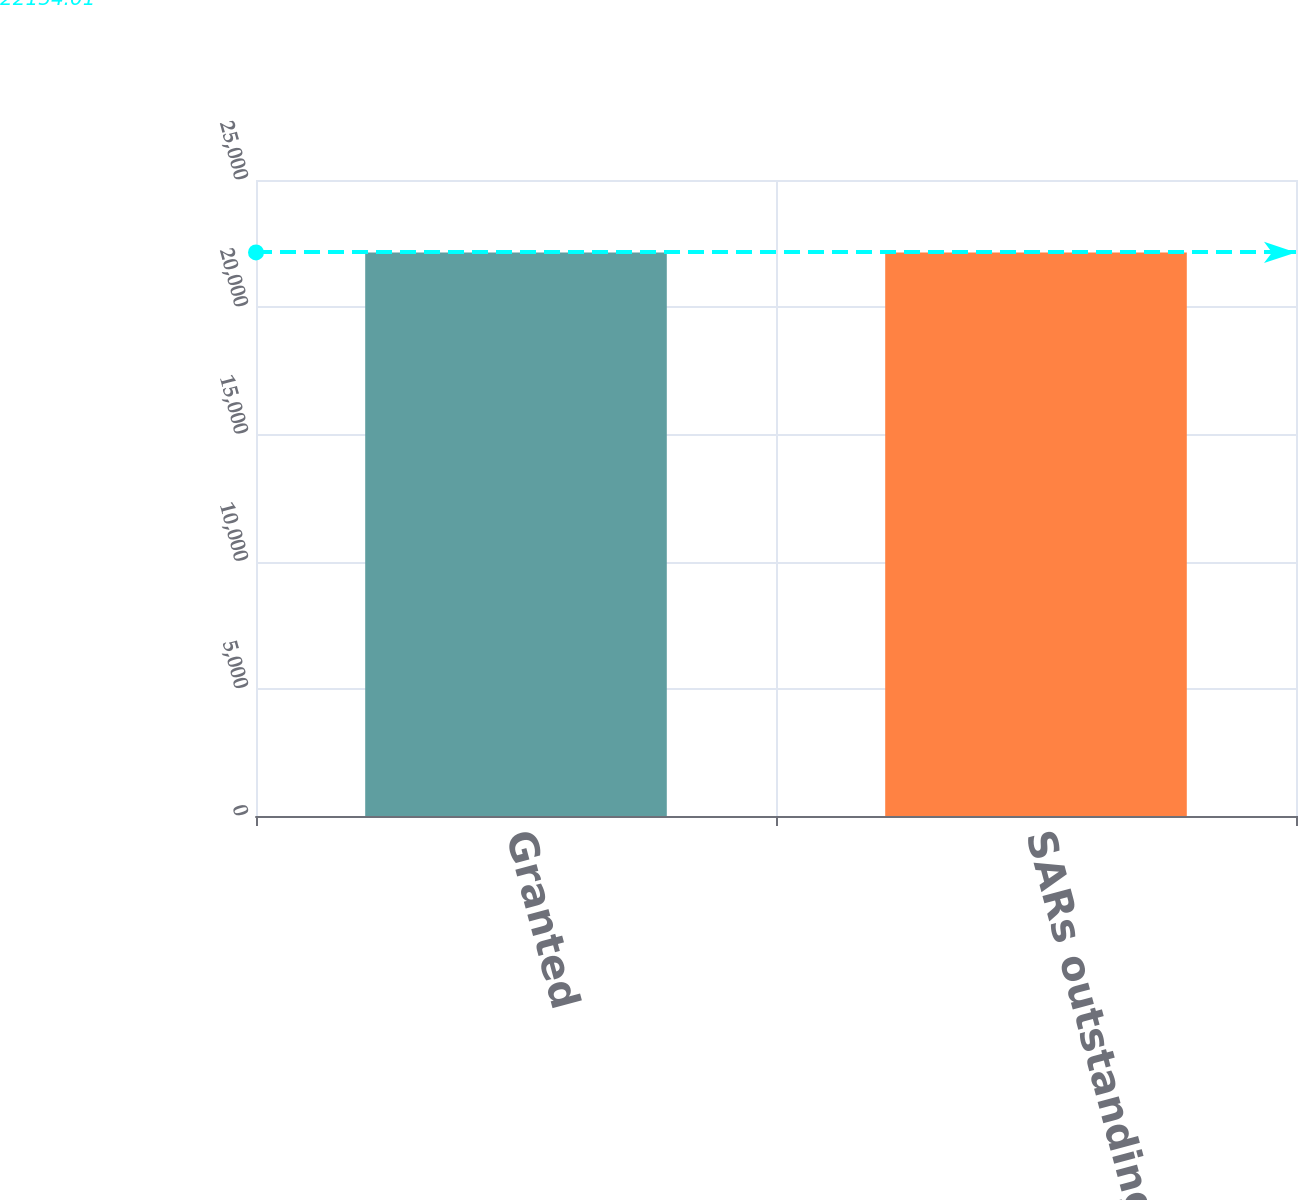Convert chart to OTSL. <chart><loc_0><loc_0><loc_500><loc_500><bar_chart><fcel>Granted<fcel>SARs outstanding December 31<nl><fcel>22154<fcel>22154.1<nl></chart> 